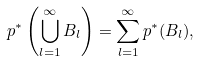<formula> <loc_0><loc_0><loc_500><loc_500>p ^ { * } \left ( \bigcup _ { l = 1 } ^ { \infty } B _ { l } \right ) = \sum _ { l = 1 } ^ { \infty } p ^ { * } ( B _ { l } ) ,</formula> 